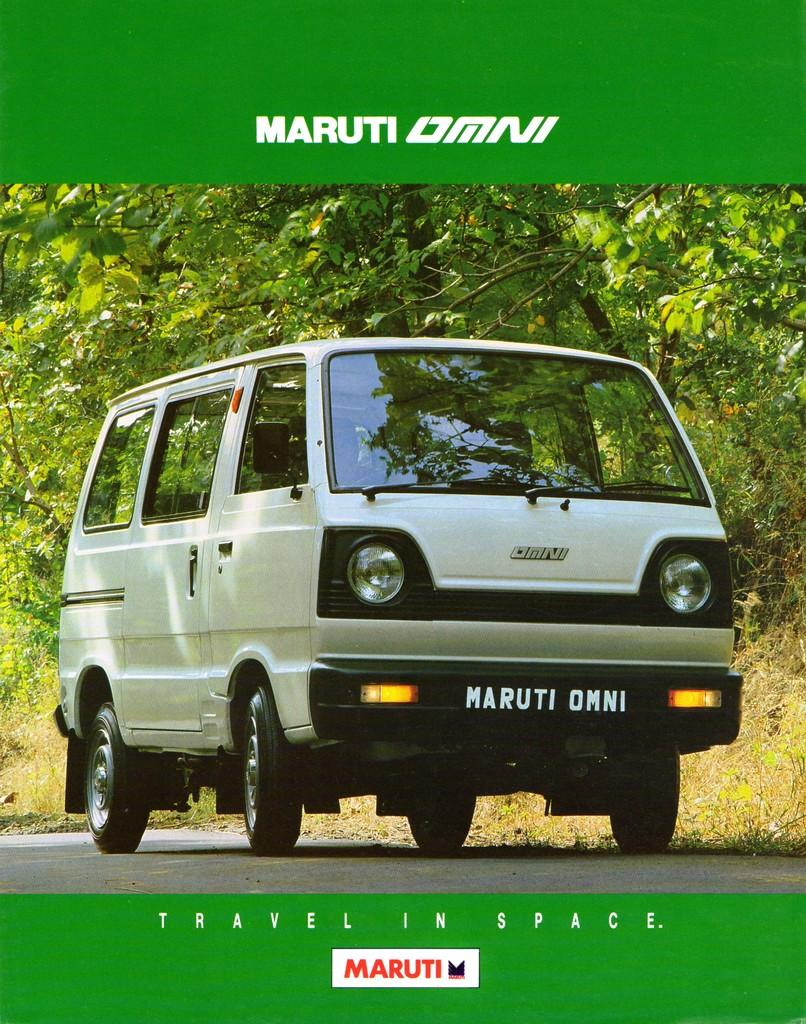What is the main subject of the image? There is a vehicle on the road in the image. What can be seen behind the vehicle? There are trees behind the vehicle in the image. What type of vegetation is visible in the image? There is grass visible in the image. What text can be seen in the image? There is some text at the top and bottom of the image. How does the toad use the system to grip the vehicle in the image? There is no toad or system present in the image; it features a vehicle on the road with trees and grass in the background. 